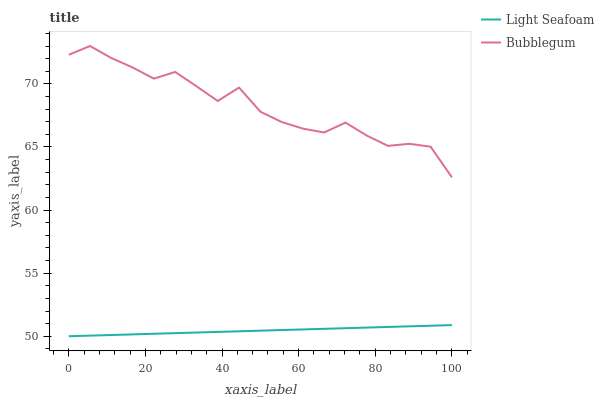Does Light Seafoam have the minimum area under the curve?
Answer yes or no. Yes. Does Bubblegum have the maximum area under the curve?
Answer yes or no. Yes. Does Bubblegum have the minimum area under the curve?
Answer yes or no. No. Is Light Seafoam the smoothest?
Answer yes or no. Yes. Is Bubblegum the roughest?
Answer yes or no. Yes. Is Bubblegum the smoothest?
Answer yes or no. No. Does Bubblegum have the lowest value?
Answer yes or no. No. Is Light Seafoam less than Bubblegum?
Answer yes or no. Yes. Is Bubblegum greater than Light Seafoam?
Answer yes or no. Yes. Does Light Seafoam intersect Bubblegum?
Answer yes or no. No. 